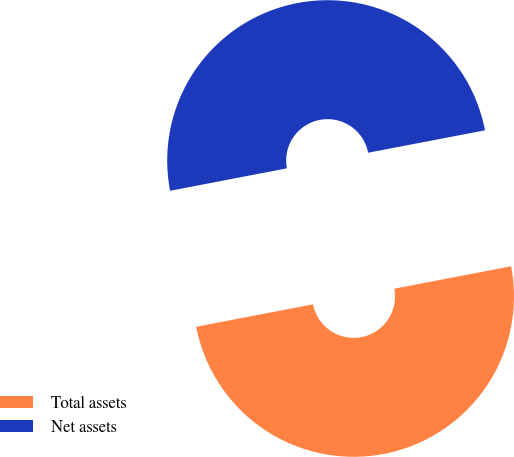Convert chart to OTSL. <chart><loc_0><loc_0><loc_500><loc_500><pie_chart><fcel>Total assets<fcel>Net assets<nl><fcel>49.99%<fcel>50.01%<nl></chart> 